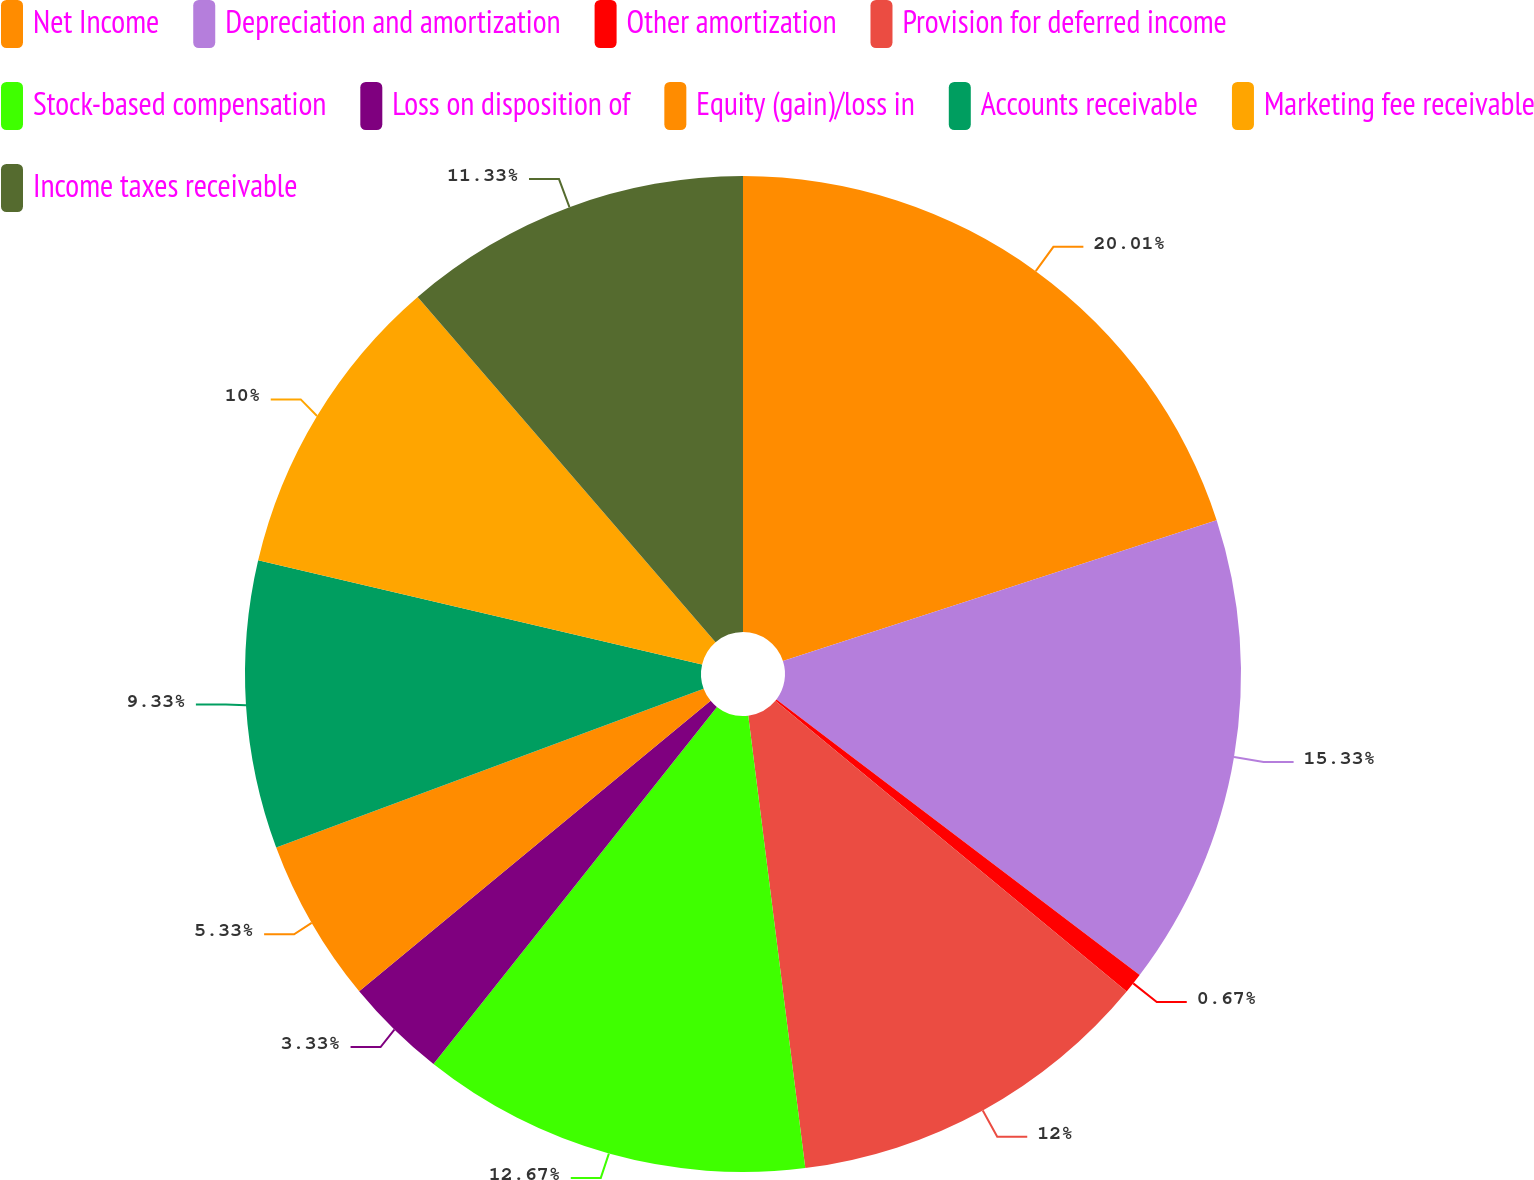<chart> <loc_0><loc_0><loc_500><loc_500><pie_chart><fcel>Net Income<fcel>Depreciation and amortization<fcel>Other amortization<fcel>Provision for deferred income<fcel>Stock-based compensation<fcel>Loss on disposition of<fcel>Equity (gain)/loss in<fcel>Accounts receivable<fcel>Marketing fee receivable<fcel>Income taxes receivable<nl><fcel>20.0%<fcel>15.33%<fcel>0.67%<fcel>12.0%<fcel>12.67%<fcel>3.33%<fcel>5.33%<fcel>9.33%<fcel>10.0%<fcel>11.33%<nl></chart> 